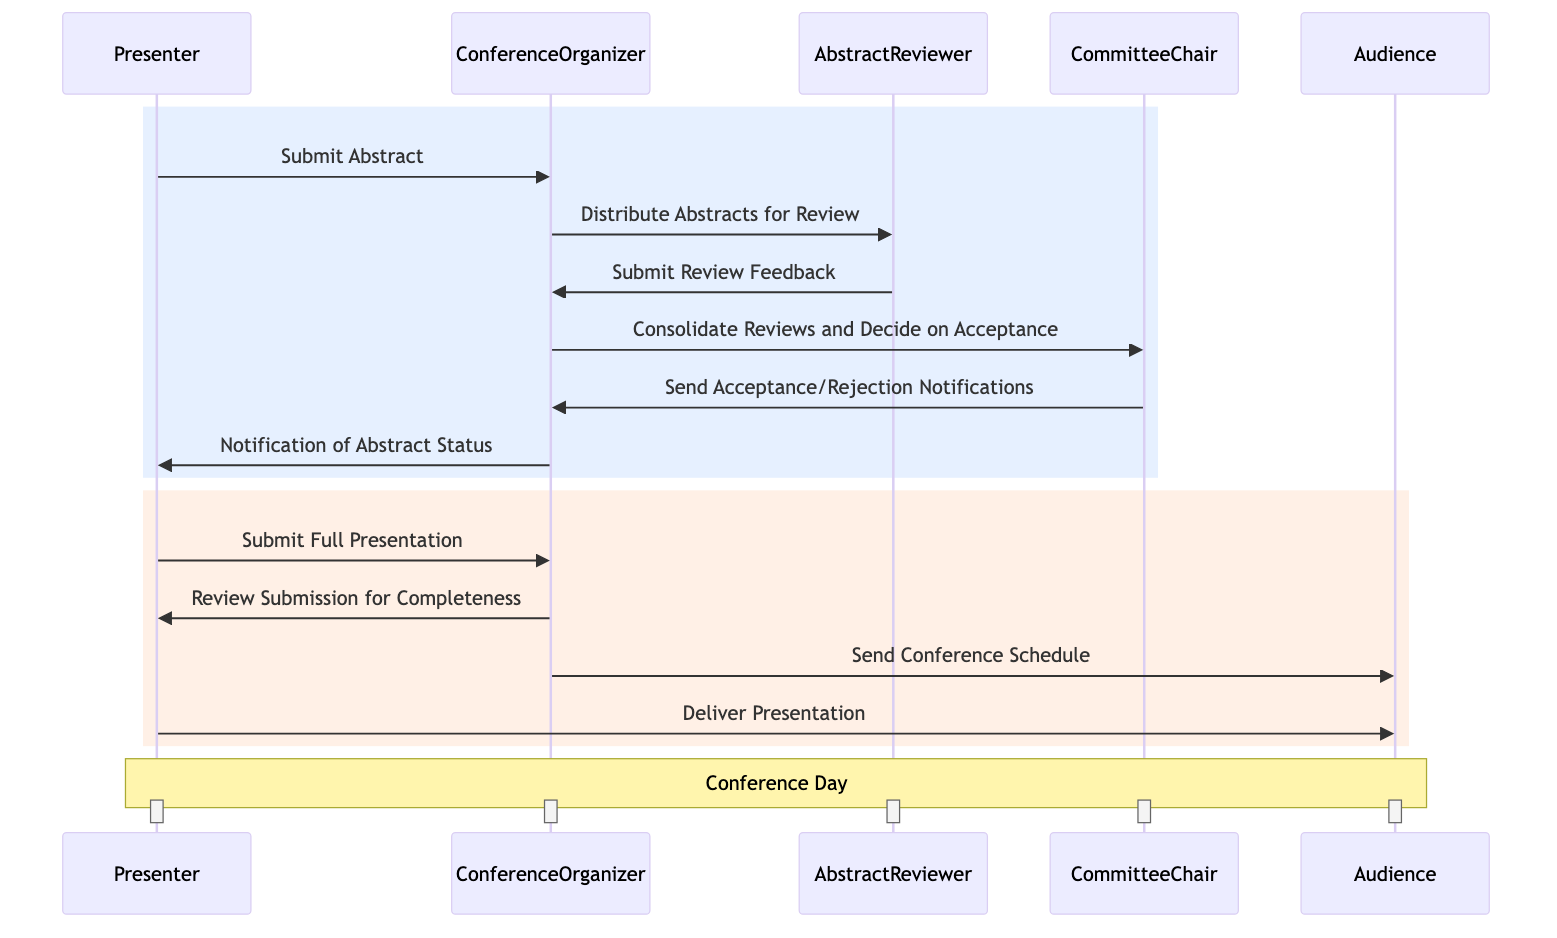What is the first action in the diagram? The first action in the diagram is initiated by the Presenter who submits an abstract to the Conference Organizer. This is the starting point of the process depicted in the sequence diagram.
Answer: Submit Abstract Who distributes the abstracts for review? The Conference Organizer is responsible for distributing the abstracts for review to the Abstract Reviewer. This is shown as a direct communication from the Conference Organizer to the Abstract Reviewer.
Answer: Conference Organizer How many main participants are involved in the conference organization process? There are five main participants involved in the process: Presenter, Conference Organizer, Abstract Reviewer, Committee Chair, and Audience. This can be counted by listing each unique entity in the diagram.
Answer: Five What happens after the Committee Chair decides on acceptance? After the Committee Chair decides on acceptance, they send acceptance or rejection notifications back to the Conference Organizer, as indicated in the flow of the diagram.
Answer: Send Acceptance/Rejection Notifications How many times does the Presenter interact with the Conference Organizer? The Presenter interacts with the Conference Organizer three times in the diagram: once to submit the abstract, once to submit the full presentation, and lastly to receive the notification of abstract status. This can be identified by tracking the arrows from the Presenter to the Conference Organizer in the diagram.
Answer: Three What is the final action performed by the Presenter? The final action performed by the Presenter is delivering the presentation to the Audience on the conference day, as indicated in the last part of the diagram.
Answer: Deliver Presentation Which entity receives the conference schedule? The Audience is the entity that receives the conference schedule from the Conference Organizer. This is a direct message shown in the flow of the diagram after the review of the full presentation.
Answer: Audience What does the Abstract Reviewer submit to the Conference Organizer? The Abstract Reviewer submits review feedback to the Conference Organizer after reviewing the abstracts, as seen in the sequence of messages in the diagram.
Answer: Submit Review Feedback 